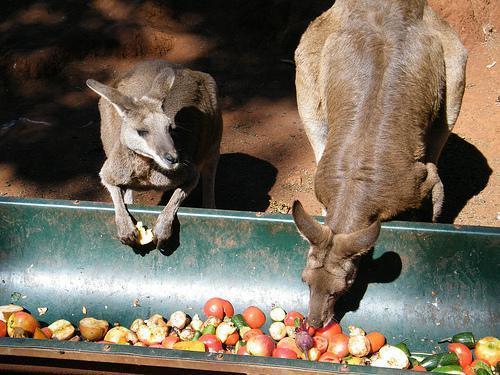How many kangaroos are there?
Give a very brief answer. 2. 